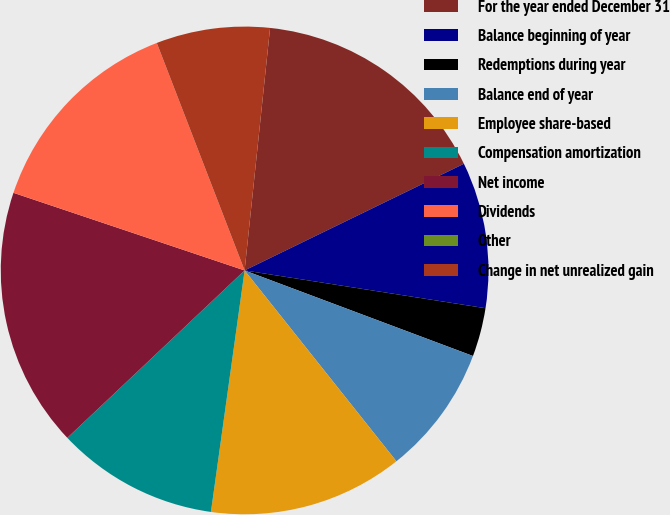Convert chart to OTSL. <chart><loc_0><loc_0><loc_500><loc_500><pie_chart><fcel>For the year ended December 31<fcel>Balance beginning of year<fcel>Redemptions during year<fcel>Balance end of year<fcel>Employee share-based<fcel>Compensation amortization<fcel>Net income<fcel>Dividends<fcel>Other<fcel>Change in net unrealized gain<nl><fcel>16.13%<fcel>9.68%<fcel>3.23%<fcel>8.6%<fcel>12.9%<fcel>10.75%<fcel>17.2%<fcel>13.98%<fcel>0.0%<fcel>7.53%<nl></chart> 